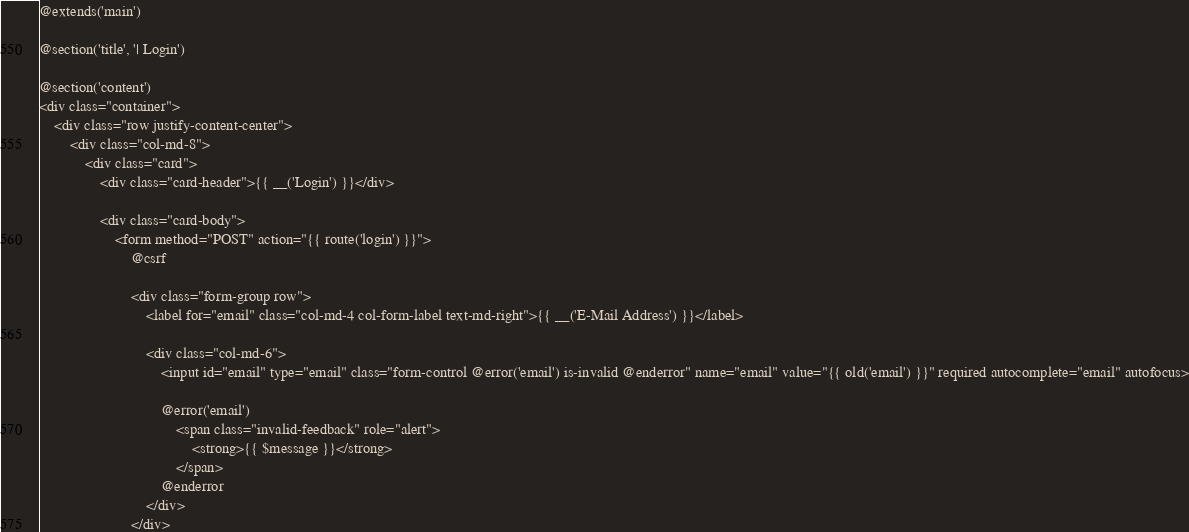<code> <loc_0><loc_0><loc_500><loc_500><_PHP_>@extends('main')

@section('title', '| Login')

@section('content')
<div class="container">
    <div class="row justify-content-center">
        <div class="col-md-8">
            <div class="card">
                <div class="card-header">{{ __('Login') }}</div>

                <div class="card-body">
                    <form method="POST" action="{{ route('login') }}">
                        @csrf

                        <div class="form-group row">
                            <label for="email" class="col-md-4 col-form-label text-md-right">{{ __('E-Mail Address') }}</label>

                            <div class="col-md-6">
                                <input id="email" type="email" class="form-control @error('email') is-invalid @enderror" name="email" value="{{ old('email') }}" required autocomplete="email" autofocus>

                                @error('email')
                                    <span class="invalid-feedback" role="alert">
                                        <strong>{{ $message }}</strong>
                                    </span>
                                @enderror
                            </div>
                        </div>
</code> 